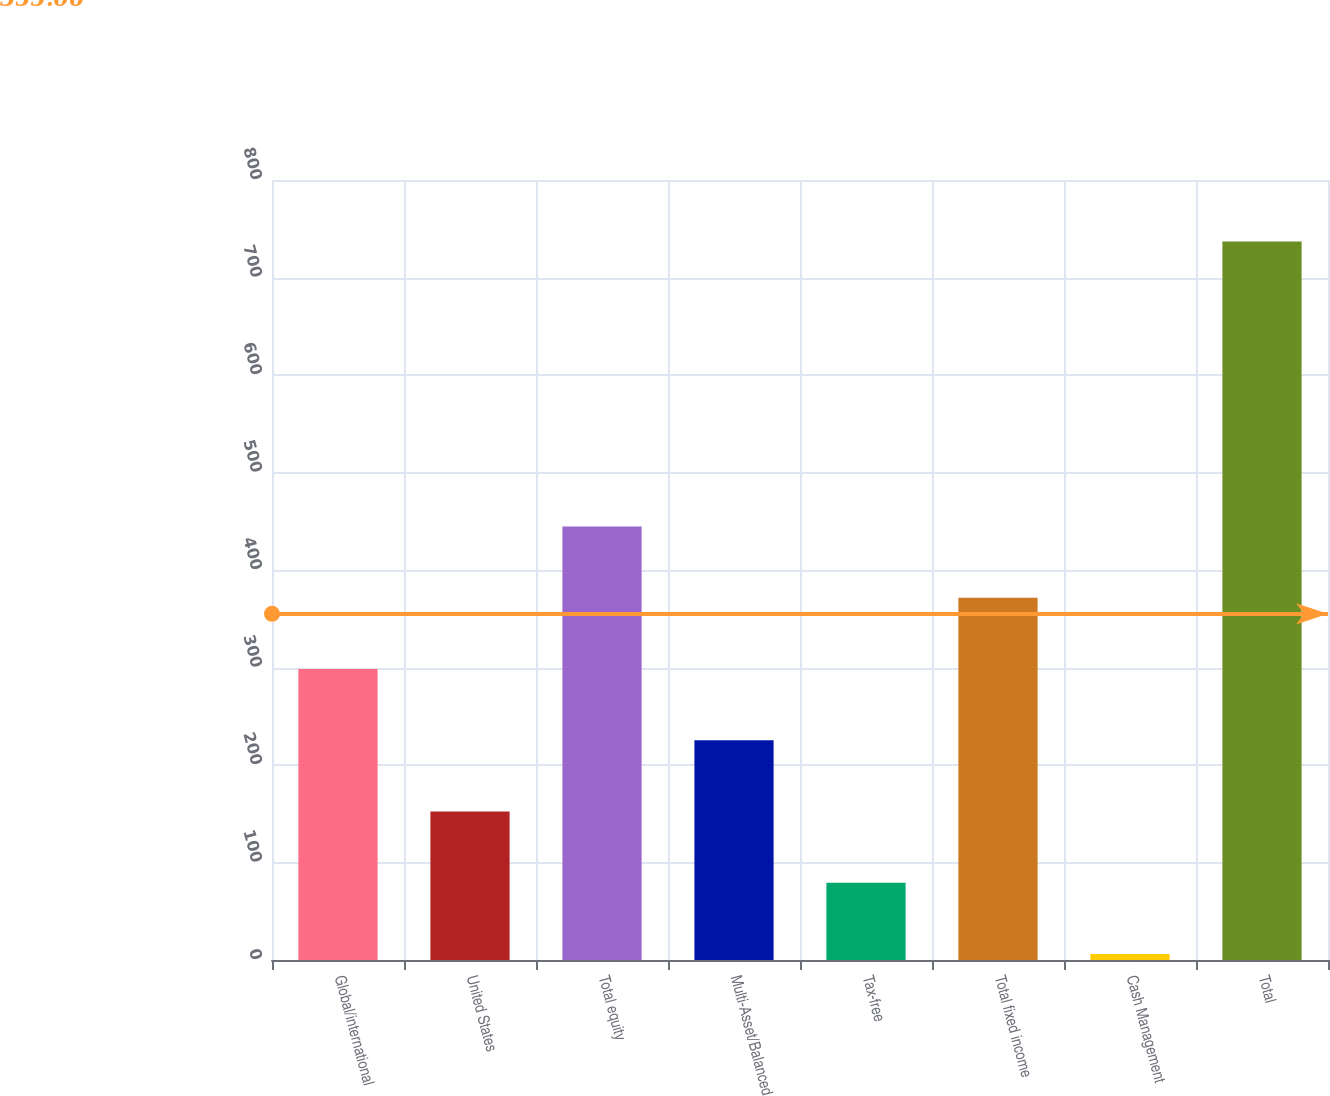Convert chart to OTSL. <chart><loc_0><loc_0><loc_500><loc_500><bar_chart><fcel>Global/international<fcel>United States<fcel>Total equity<fcel>Multi-Asset/Balanced<fcel>Tax-free<fcel>Total fixed income<fcel>Cash Management<fcel>Total<nl><fcel>298.48<fcel>152.34<fcel>444.62<fcel>225.41<fcel>79.27<fcel>371.55<fcel>6.2<fcel>736.9<nl></chart> 